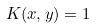<formula> <loc_0><loc_0><loc_500><loc_500>K ( x , y ) = 1</formula> 